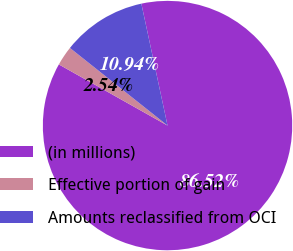Convert chart to OTSL. <chart><loc_0><loc_0><loc_500><loc_500><pie_chart><fcel>(in millions)<fcel>Effective portion of gain<fcel>Amounts reclassified from OCI<nl><fcel>86.53%<fcel>2.54%<fcel>10.94%<nl></chart> 